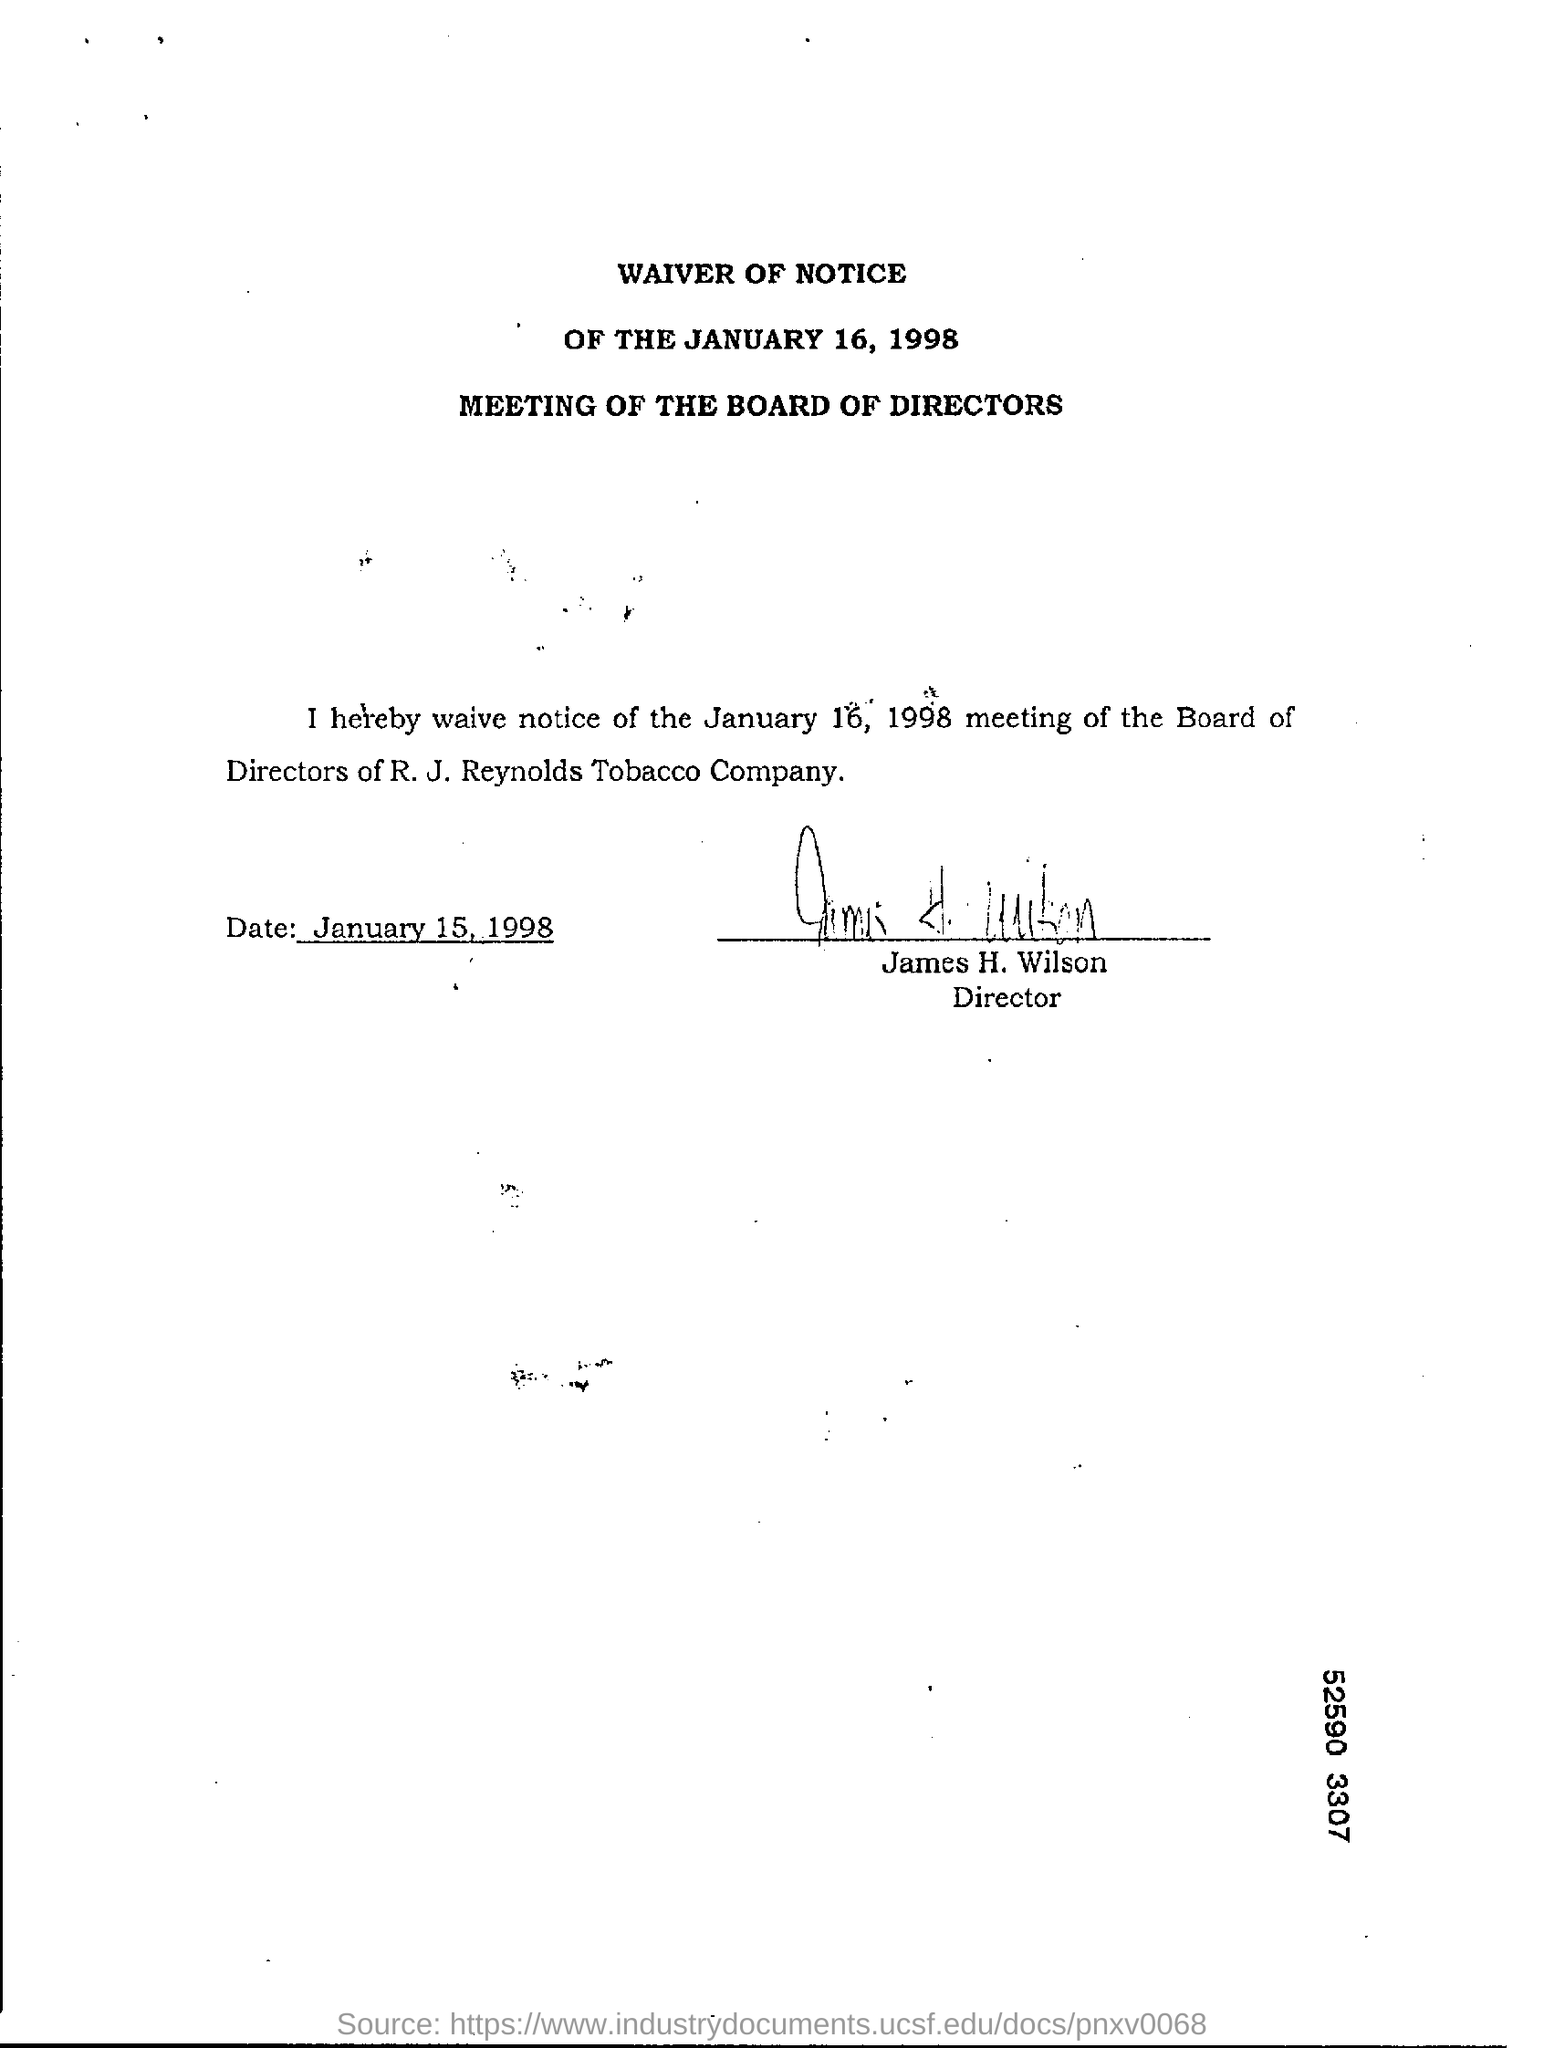Draw attention to some important aspects in this diagram. The name of the Director is James H. Wilson. The R. J. Reynolds Tobacco Company is the name of the company. The document was signed on January 15, 1998. 